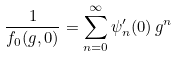<formula> <loc_0><loc_0><loc_500><loc_500>\frac { 1 } { f _ { 0 } ( g , 0 ) } = \sum _ { n = 0 } ^ { \infty } \psi ^ { \prime } _ { n } ( 0 ) \, g ^ { n }</formula> 